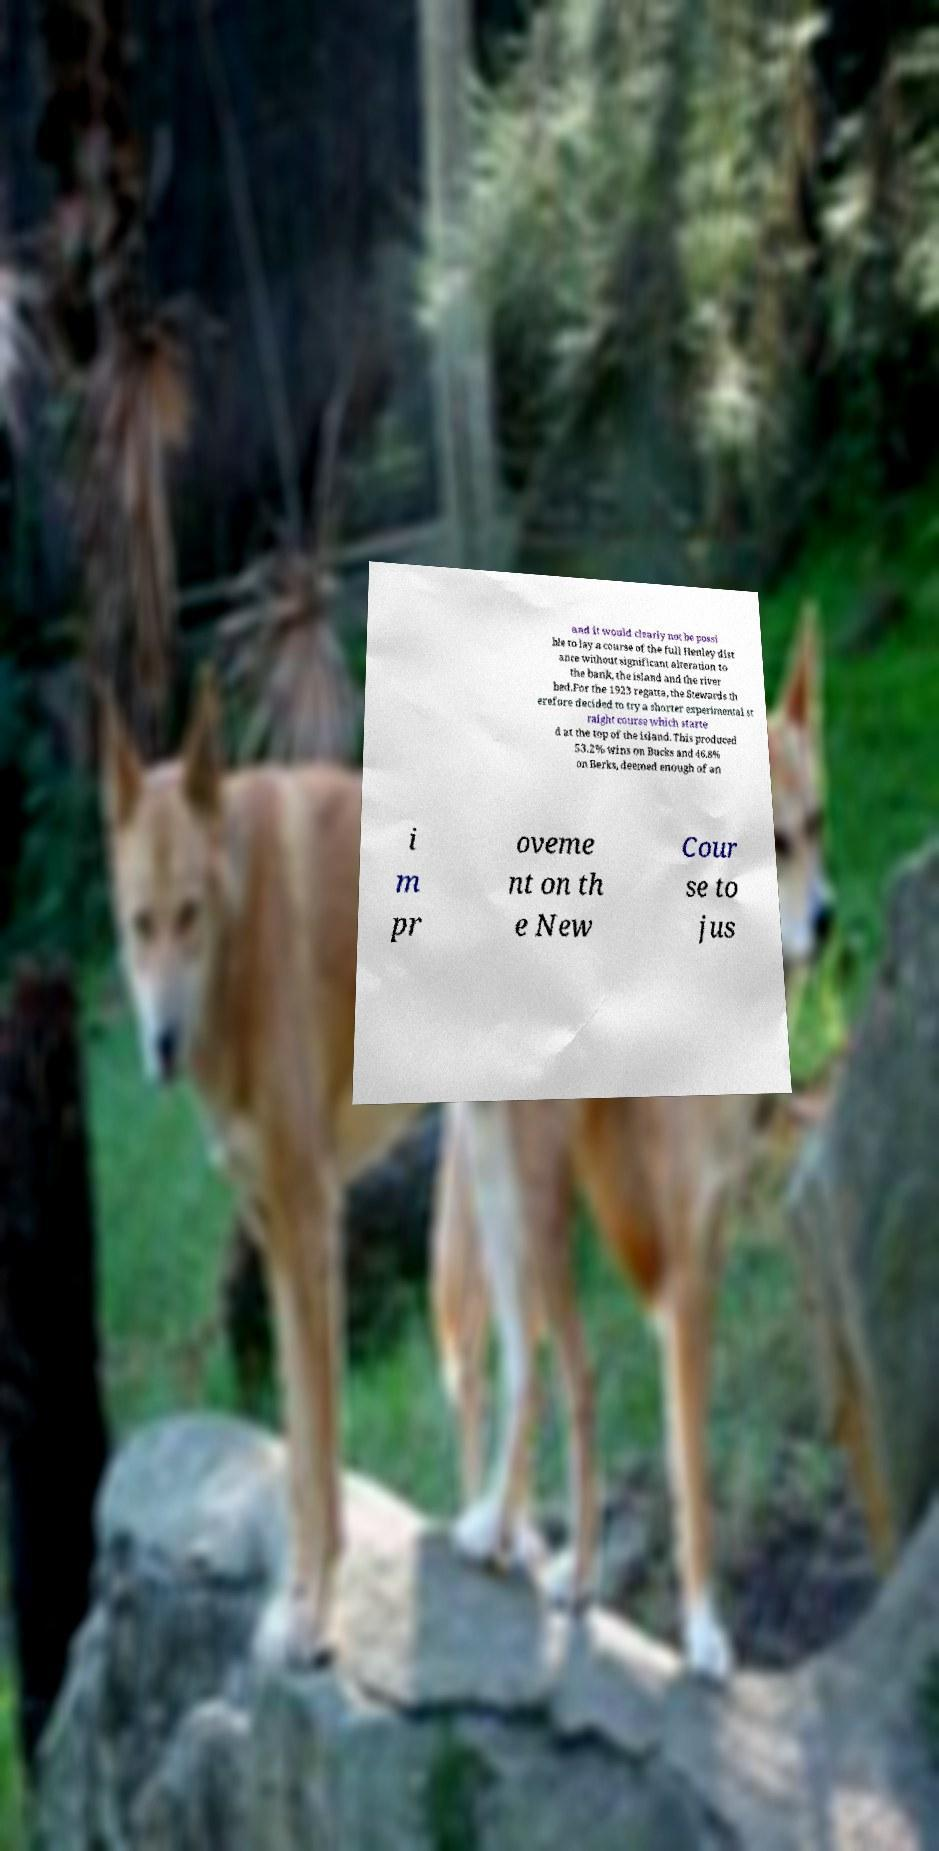Please identify and transcribe the text found in this image. and it would clearly not be possi ble to lay a course of the full Henley dist ance without significant alteration to the bank, the island and the river bed.For the 1923 regatta, the Stewards th erefore decided to try a shorter experimental st raight course which starte d at the top of the island. This produced 53.2% wins on Bucks and 46.8% on Berks, deemed enough of an i m pr oveme nt on th e New Cour se to jus 